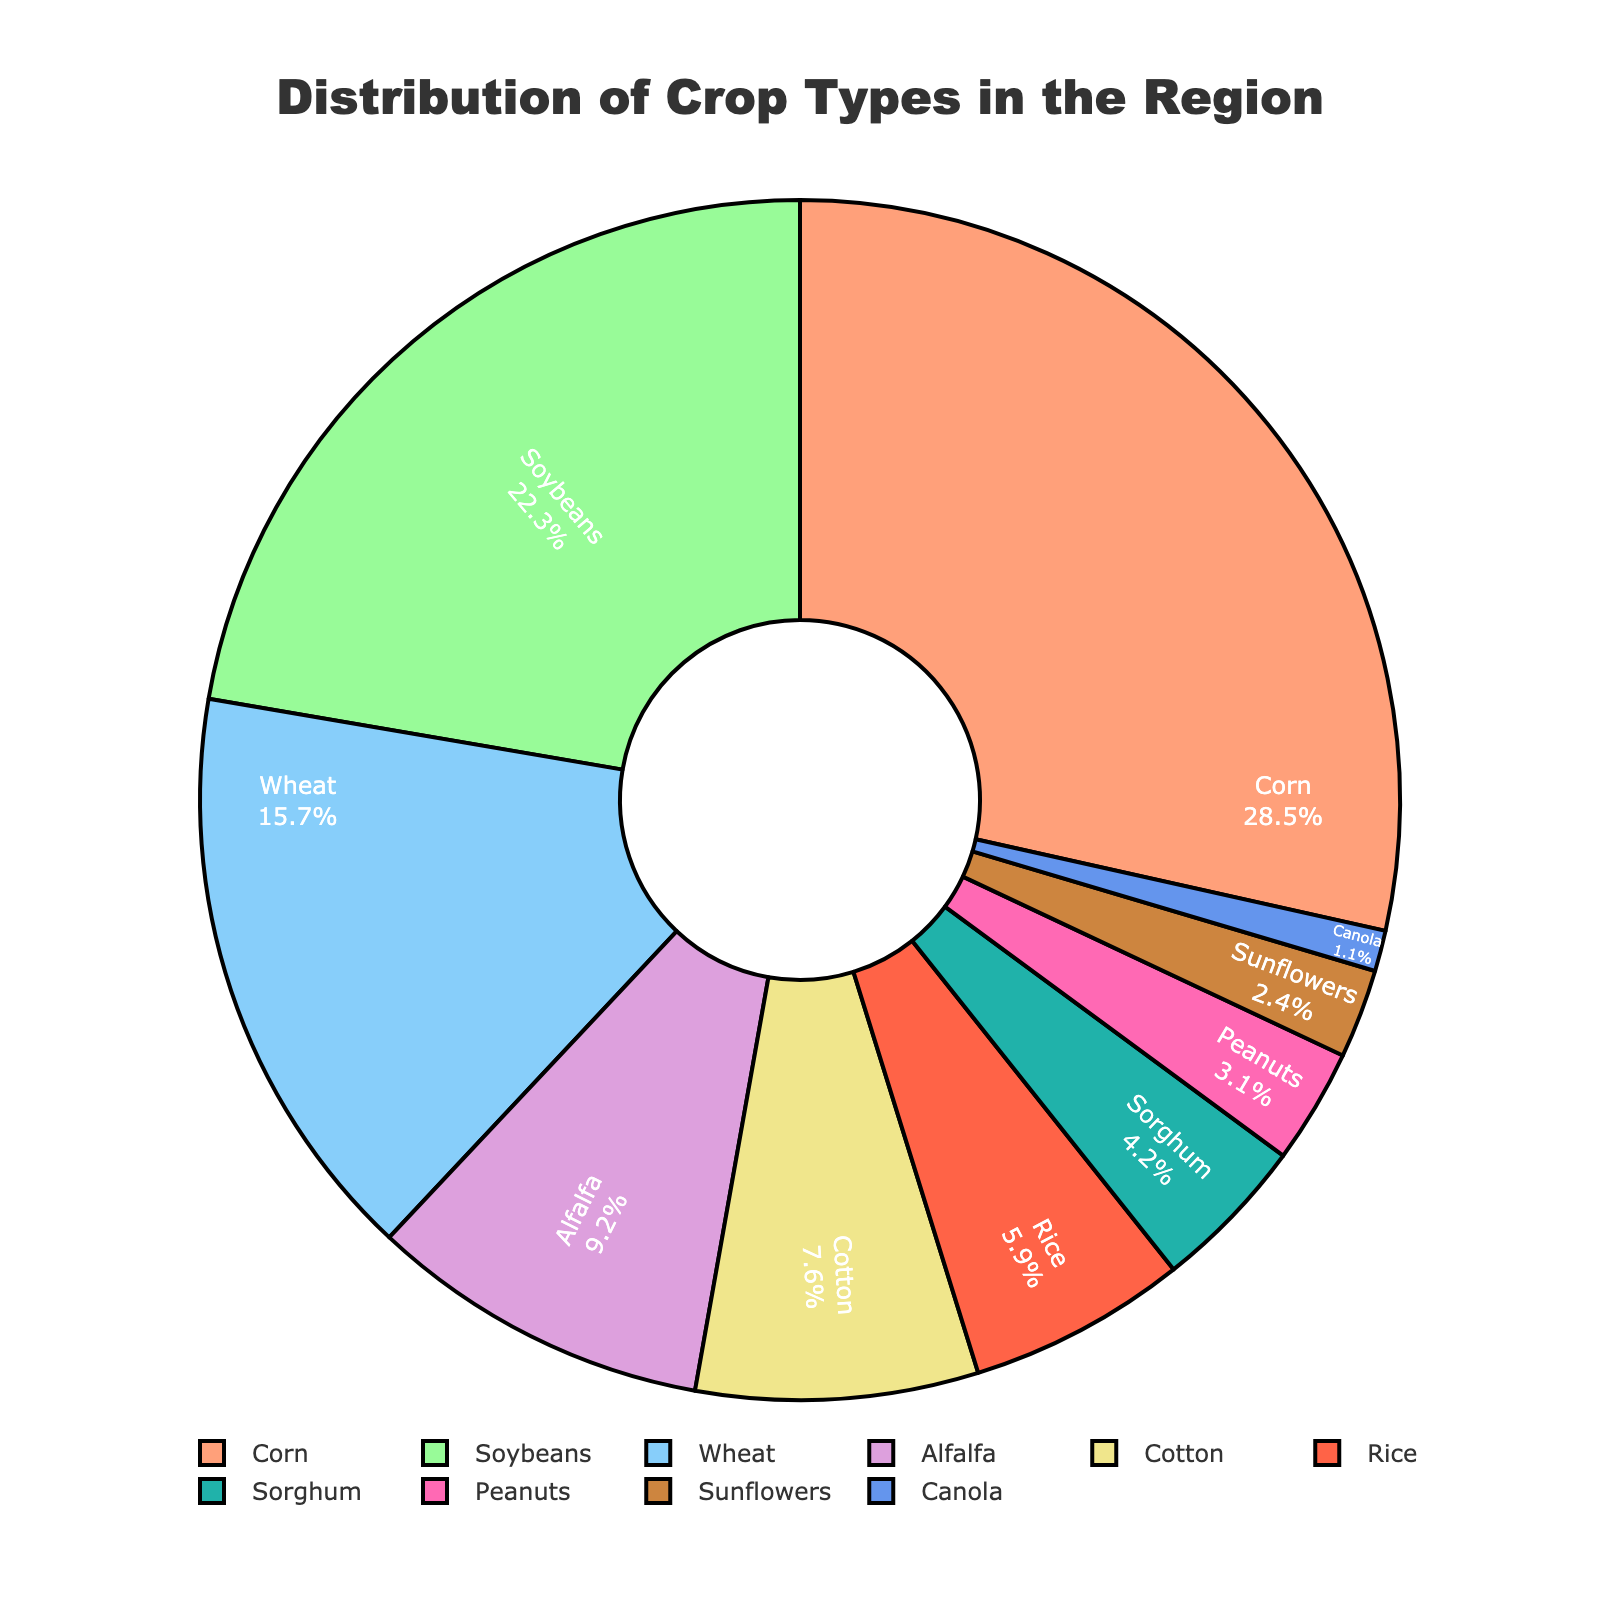What's the most common crop type in the region? The pie chart shows the distribution of crop types with percentages. The largest segment represents the most common crop type.
Answer: Corn Which crop type has the smallest percentage of coverage? The pie chart labels indicate the crop types and their corresponding percentages. The smallest percentage points to the least common crop type.
Answer: Canola What is the combined percentage of Corn and Soybeans? Add the percentages of Corn and Soybeans: 28.5% (Corn) + 22.3% (Soybeans) = 50.8%.
Answer: 50.8% Which crop has a larger percentage, Wheat or Alfalfa? Compare the percentages of Wheat and Alfalfa. Wheat has 15.7% and Alfalfa has 9.2%.
Answer: Wheat Is the percentage of Rice greater than or less than the combined percentage of Sorghum and Peanuts? Compare the percentage of Rice (5.9%) with the sum of Sorghum (4.2%) and Peanuts (3.1%): 5.9% vs. 7.3%.
Answer: Less than What is the total percentage coverage of Cotton, Rice, and Peanuts? Add the percentages: Cotton (7.6%) + Rice (5.9%) + Peanuts (3.1%) = 16.6%.
Answer: 16.6% Which farming crop is represented by the light green color in the pie chart? Identify the crop type matching the light green color segment; the legend indicates it as Soybeans.
Answer: Soybeans Are there more crop types with more than 10% coverage or less than 10% coverage? Count the crop types above 10%: Corn, Soybeans, Wheat (3). Count below 10%: Alfalfa, Cotton, Rice, Sorghum, Peanuts, Sunflowers, Canola (7).
Answer: Less than 10% coverage Calculate the difference in percentage coverage between Sunflowers and Canola. Subtract the percentage of Canola (1.1%) from Sunflowers (2.4%): 2.4% - 1.1% = 1.3%.
Answer: 1.3% 